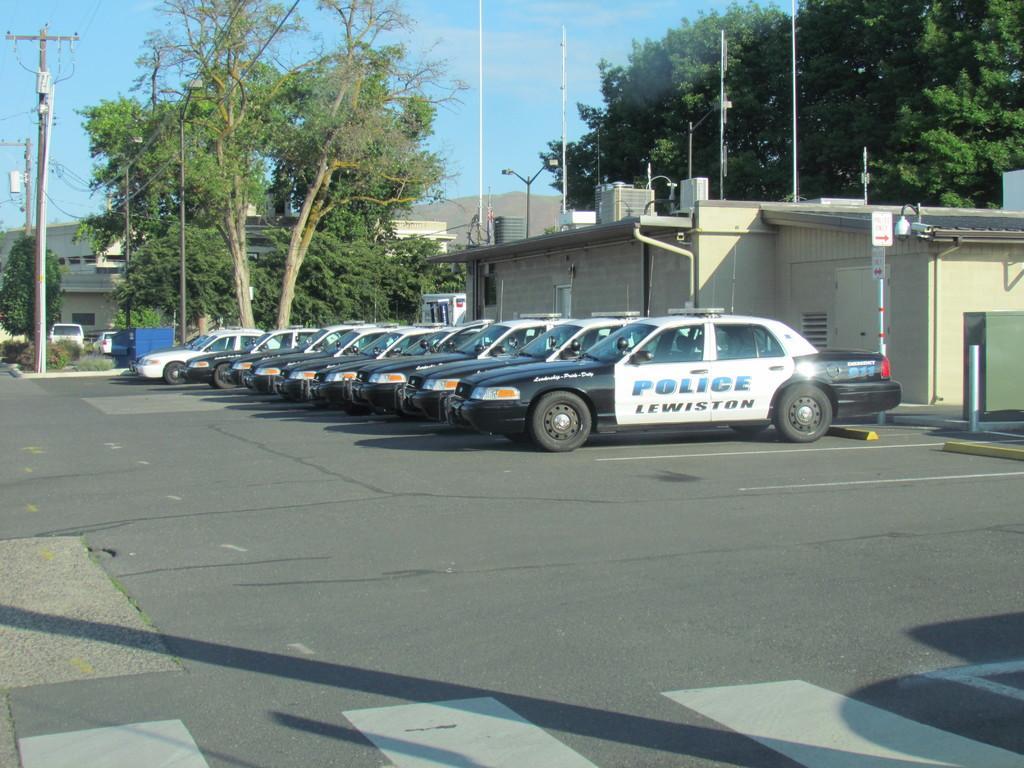How would you summarize this image in a sentence or two? In this image, we can see vehicles on the road and in the background, there are trees, buildings and poles along with wires. 